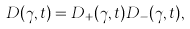<formula> <loc_0><loc_0><loc_500><loc_500>D ( \gamma , t ) = D _ { + } ( \gamma , t ) D _ { - } ( \gamma , t ) ,</formula> 